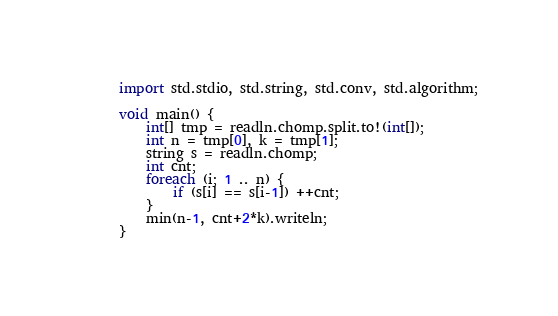<code> <loc_0><loc_0><loc_500><loc_500><_D_>import std.stdio, std.string, std.conv, std.algorithm;

void main() {
    int[] tmp = readln.chomp.split.to!(int[]);
    int n = tmp[0], k = tmp[1];
    string s = readln.chomp;
    int cnt;
    foreach (i; 1 .. n) {
        if (s[i] == s[i-1]) ++cnt;
    }
    min(n-1, cnt+2*k).writeln;
}</code> 